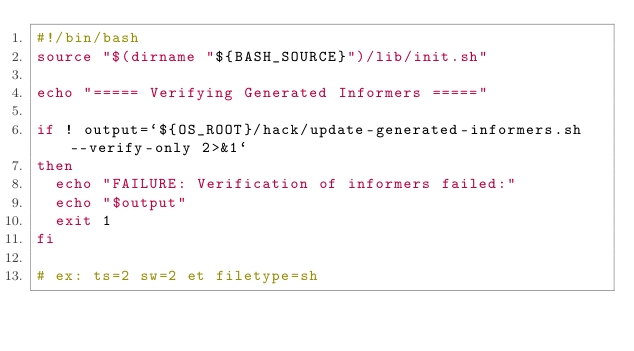Convert code to text. <code><loc_0><loc_0><loc_500><loc_500><_Bash_>#!/bin/bash
source "$(dirname "${BASH_SOURCE}")/lib/init.sh"

echo "===== Verifying Generated Informers ====="

if ! output=`${OS_ROOT}/hack/update-generated-informers.sh --verify-only 2>&1`
then
  echo "FAILURE: Verification of informers failed:"
  echo "$output"
  exit 1
fi

# ex: ts=2 sw=2 et filetype=sh
</code> 